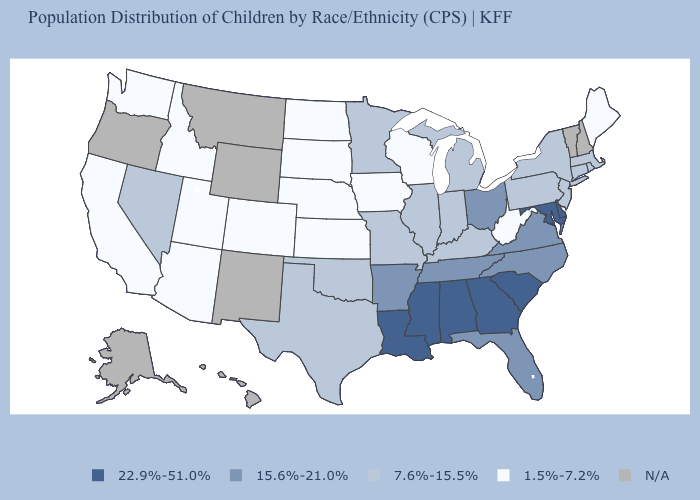Name the states that have a value in the range 15.6%-21.0%?
Quick response, please. Arkansas, Florida, North Carolina, Ohio, Tennessee, Virginia. What is the highest value in the USA?
Be succinct. 22.9%-51.0%. What is the value of West Virginia?
Concise answer only. 1.5%-7.2%. Name the states that have a value in the range 7.6%-15.5%?
Quick response, please. Connecticut, Illinois, Indiana, Kentucky, Massachusetts, Michigan, Minnesota, Missouri, Nevada, New Jersey, New York, Oklahoma, Pennsylvania, Rhode Island, Texas. Does the first symbol in the legend represent the smallest category?
Be succinct. No. Does the map have missing data?
Concise answer only. Yes. Which states have the lowest value in the Northeast?
Quick response, please. Maine. Is the legend a continuous bar?
Write a very short answer. No. Among the states that border North Dakota , which have the highest value?
Short answer required. Minnesota. Does the map have missing data?
Give a very brief answer. Yes. What is the value of Washington?
Be succinct. 1.5%-7.2%. Which states have the highest value in the USA?
Concise answer only. Alabama, Delaware, Georgia, Louisiana, Maryland, Mississippi, South Carolina. What is the value of Missouri?
Short answer required. 7.6%-15.5%. Among the states that border Delaware , does New Jersey have the lowest value?
Quick response, please. Yes. What is the lowest value in the USA?
Answer briefly. 1.5%-7.2%. 